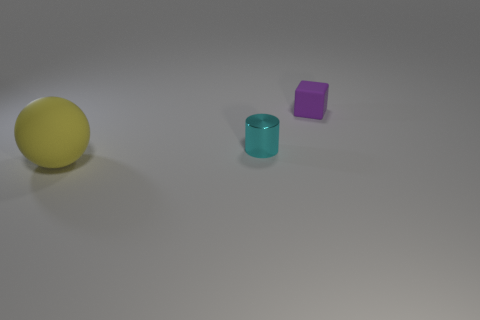Add 1 cyan shiny things. How many objects exist? 4 Subtract all blocks. How many objects are left? 2 Subtract all large spheres. Subtract all cyan metal cylinders. How many objects are left? 1 Add 3 large rubber things. How many large rubber things are left? 4 Add 1 yellow balls. How many yellow balls exist? 2 Subtract 0 red balls. How many objects are left? 3 